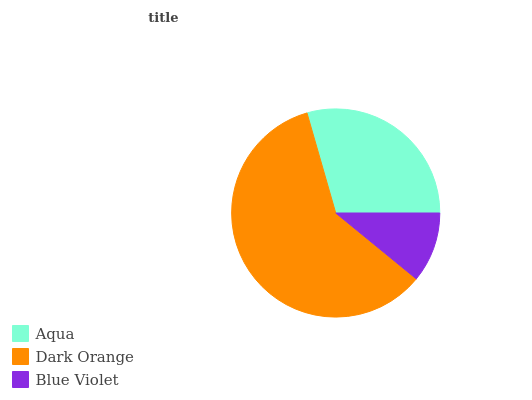Is Blue Violet the minimum?
Answer yes or no. Yes. Is Dark Orange the maximum?
Answer yes or no. Yes. Is Dark Orange the minimum?
Answer yes or no. No. Is Blue Violet the maximum?
Answer yes or no. No. Is Dark Orange greater than Blue Violet?
Answer yes or no. Yes. Is Blue Violet less than Dark Orange?
Answer yes or no. Yes. Is Blue Violet greater than Dark Orange?
Answer yes or no. No. Is Dark Orange less than Blue Violet?
Answer yes or no. No. Is Aqua the high median?
Answer yes or no. Yes. Is Aqua the low median?
Answer yes or no. Yes. Is Dark Orange the high median?
Answer yes or no. No. Is Blue Violet the low median?
Answer yes or no. No. 